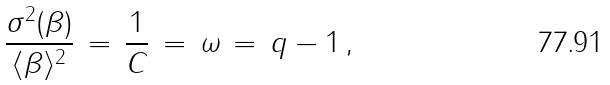Convert formula to latex. <formula><loc_0><loc_0><loc_500><loc_500>\frac { \sigma ^ { 2 } ( \beta ) } { \langle \beta \rangle ^ { 2 } } \, = \, \frac { 1 } { C } \, = \, \omega \, = \, q - 1 \, ,</formula> 